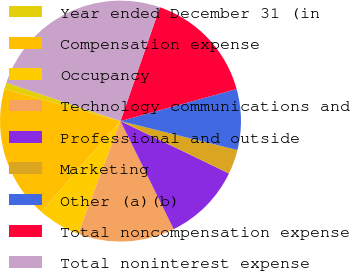<chart> <loc_0><loc_0><loc_500><loc_500><pie_chart><fcel>Year ended December 31 (in<fcel>Compensation expense<fcel>Occupancy<fcel>Technology communications and<fcel>Professional and outside<fcel>Marketing<fcel>Other (a)(b)<fcel>Total noncompensation expense<fcel>Total noninterest expense<nl><fcel>0.87%<fcel>17.85%<fcel>5.72%<fcel>13.0%<fcel>10.57%<fcel>3.29%<fcel>8.15%<fcel>15.42%<fcel>25.13%<nl></chart> 